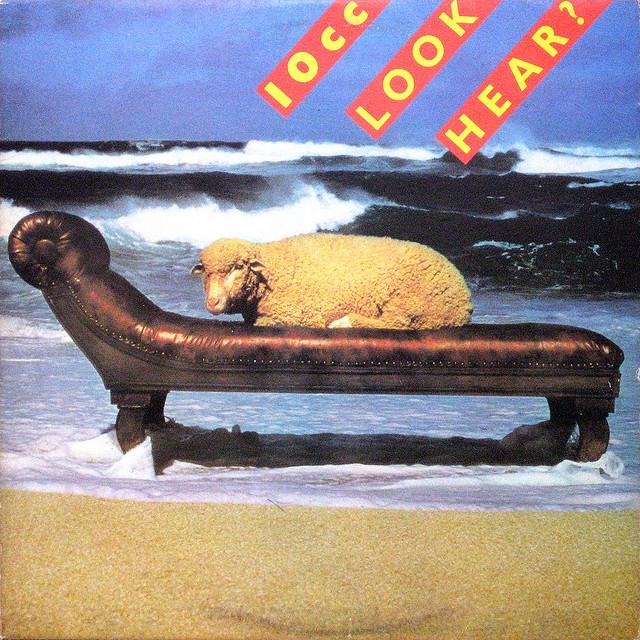Is the chair on the water?
Quick response, please. Yes. What is sitting on the lounge chair?
Write a very short answer. Sheep. What is the name of the chair?
Keep it brief. Chaise. 